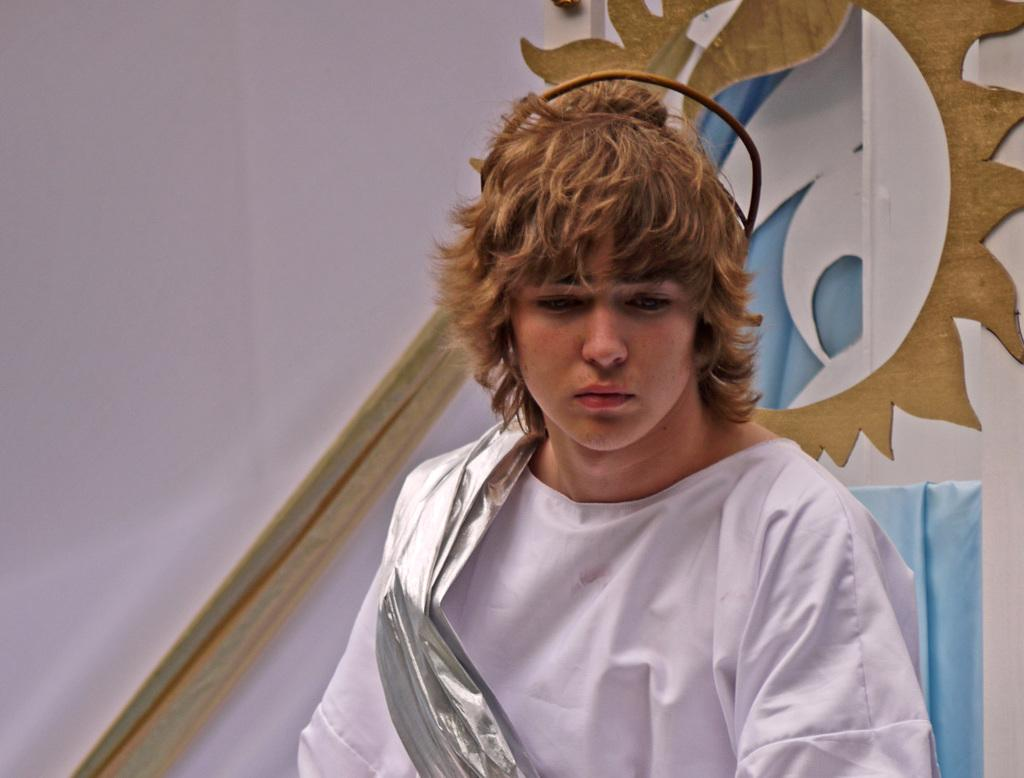Who or what is the main subject of the image? There is a person in the image. What can be observed about the person's attire? The person is wearing white clothes. What is the person's posture in the image? The person is standing. What can be seen behind the person in the image? There is a wall in the background of the image. What type of detail can be seen on the person's uncle's shirt in the image? There is no uncle present in the image, and therefore no shirt or detail to observe. 